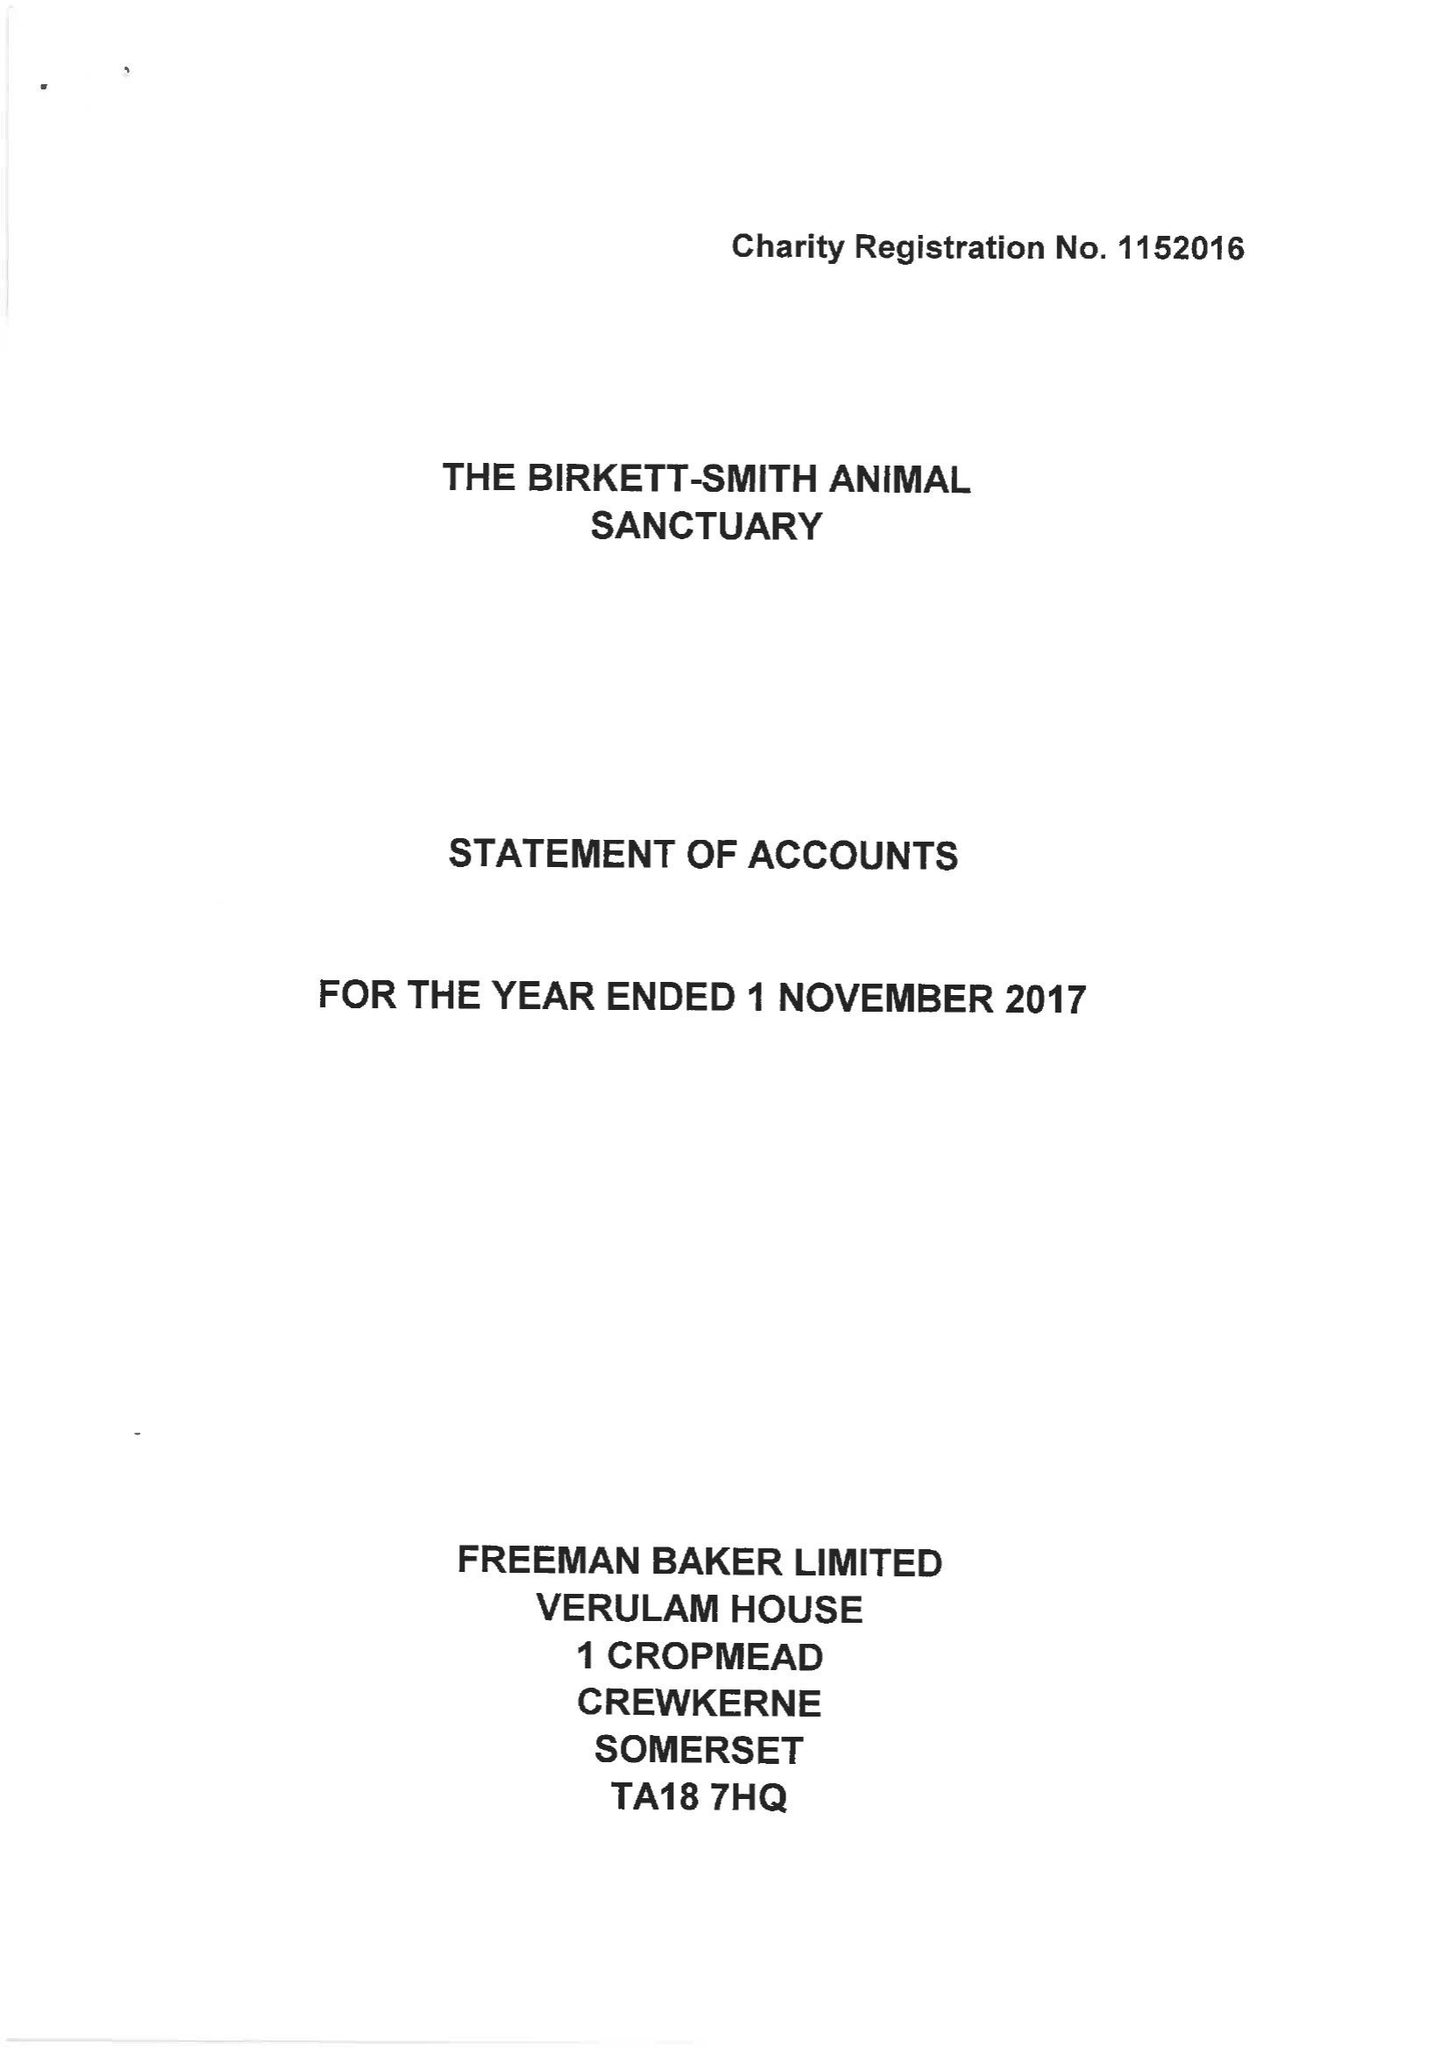What is the value for the report_date?
Answer the question using a single word or phrase. 2017-11-01 